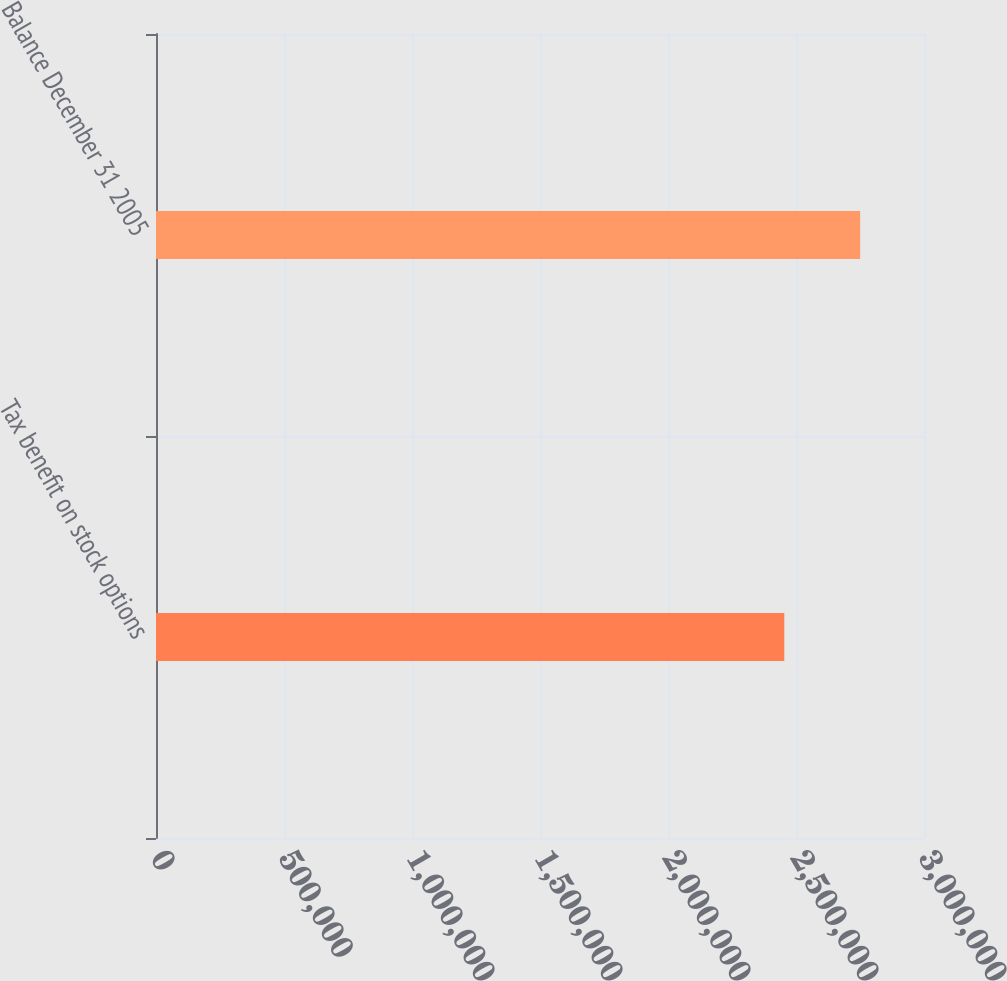<chart> <loc_0><loc_0><loc_500><loc_500><bar_chart><fcel>Tax benefit on stock options<fcel>Balance December 31 2005<nl><fcel>2.45422e+06<fcel>2.75057e+06<nl></chart> 